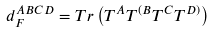Convert formula to latex. <formula><loc_0><loc_0><loc_500><loc_500>d _ { F } ^ { A B C D } = T r \left ( T ^ { A } T ^ { ( B } T ^ { C } T ^ { D ) } \right )</formula> 